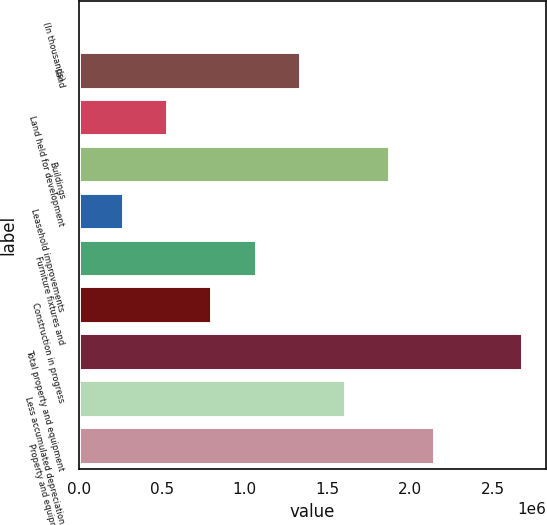<chart> <loc_0><loc_0><loc_500><loc_500><bar_chart><fcel>(In thousands)<fcel>Land<fcel>Land held for development<fcel>Buildings<fcel>Leasehold improvements<fcel>Furniture fixtures and<fcel>Construction in progress<fcel>Total property and equipment<fcel>Less accumulated depreciation<fcel>Property and equipment net<nl><fcel>2015<fcel>1.34363e+06<fcel>538661<fcel>1.88028e+06<fcel>270338<fcel>1.07531e+06<fcel>806984<fcel>2.68524e+06<fcel>1.61195e+06<fcel>2.1486e+06<nl></chart> 